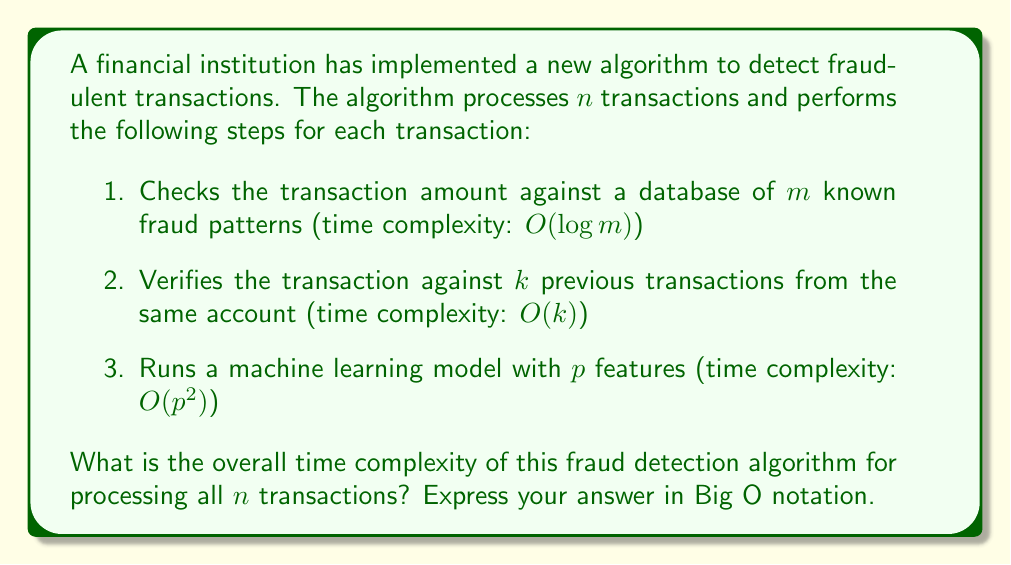What is the answer to this math problem? To determine the overall time complexity, we need to analyze each step of the algorithm and combine them:

1. For each transaction, checking against $m$ fraud patterns takes $O(\log m)$ time.

2. Verifying against $k$ previous transactions takes $O(k)$ time.

3. Running the machine learning model with $p$ features takes $O(p^2)$ time.

These steps are performed for each of the $n$ transactions. Therefore, the time complexity for a single transaction is:

$O(\log m + k + p^2)$

To process all $n$ transactions, we multiply this by $n$:

$O(n(\log m + k + p^2))$

We can simplify this expression by considering the dominant term. Since $p^2$ is likely to be larger than $\log m$ and $k$ for most practical scenarios (assuming $p$ is not very small), we can approximate the time complexity as:

$O(np^2)$

This simplified form represents the worst-case scenario and is more intuitive for analysis. However, if in a specific context $k$ or $\log m$ were to be significantly larger than $p^2$, we would need to keep the full expression.
Answer: $O(np^2)$ 